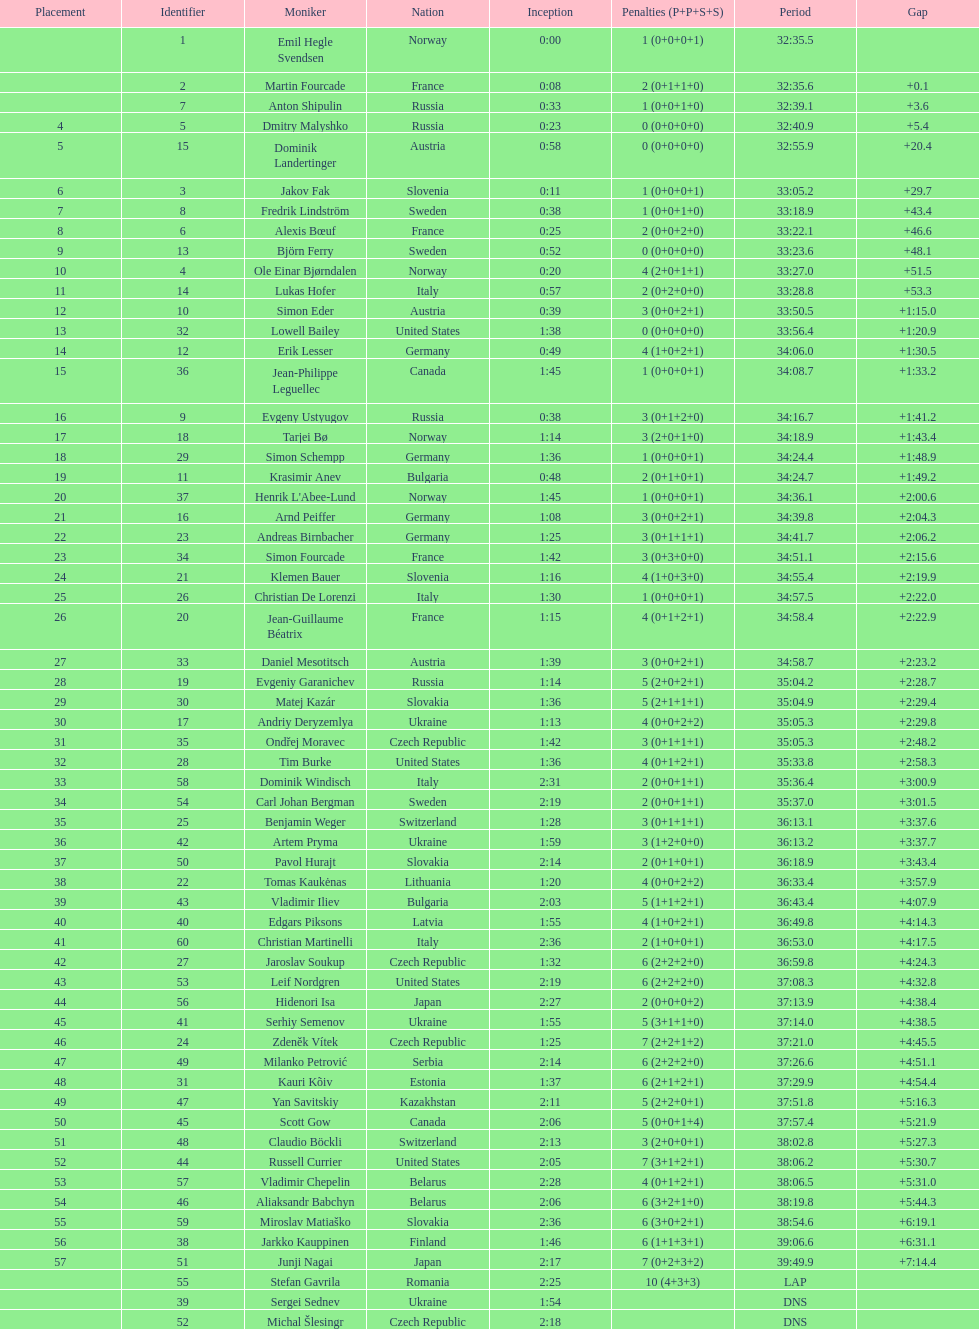What is the total number of participants between norway and france? 7. 